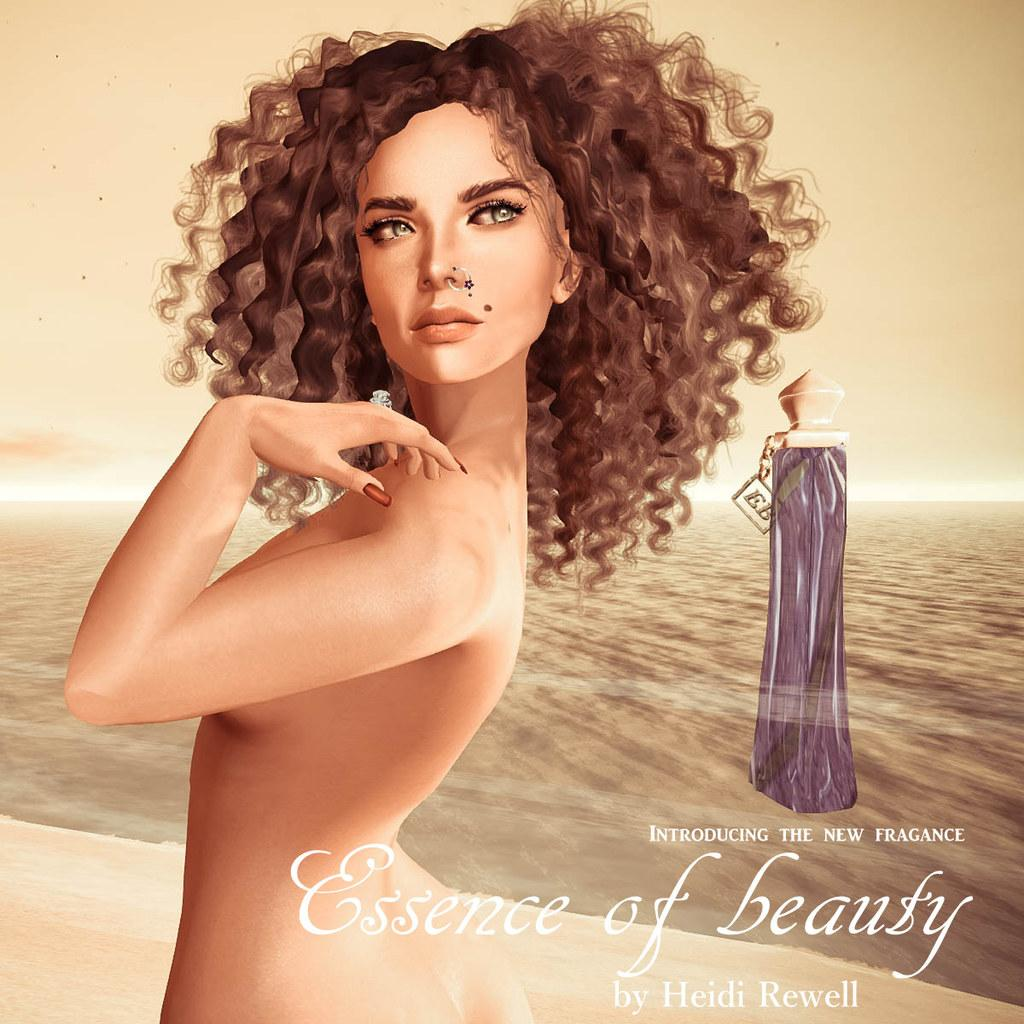Provide a one-sentence caption for the provided image. Poster showing a woman posing and the words "Essence of Beauty". 